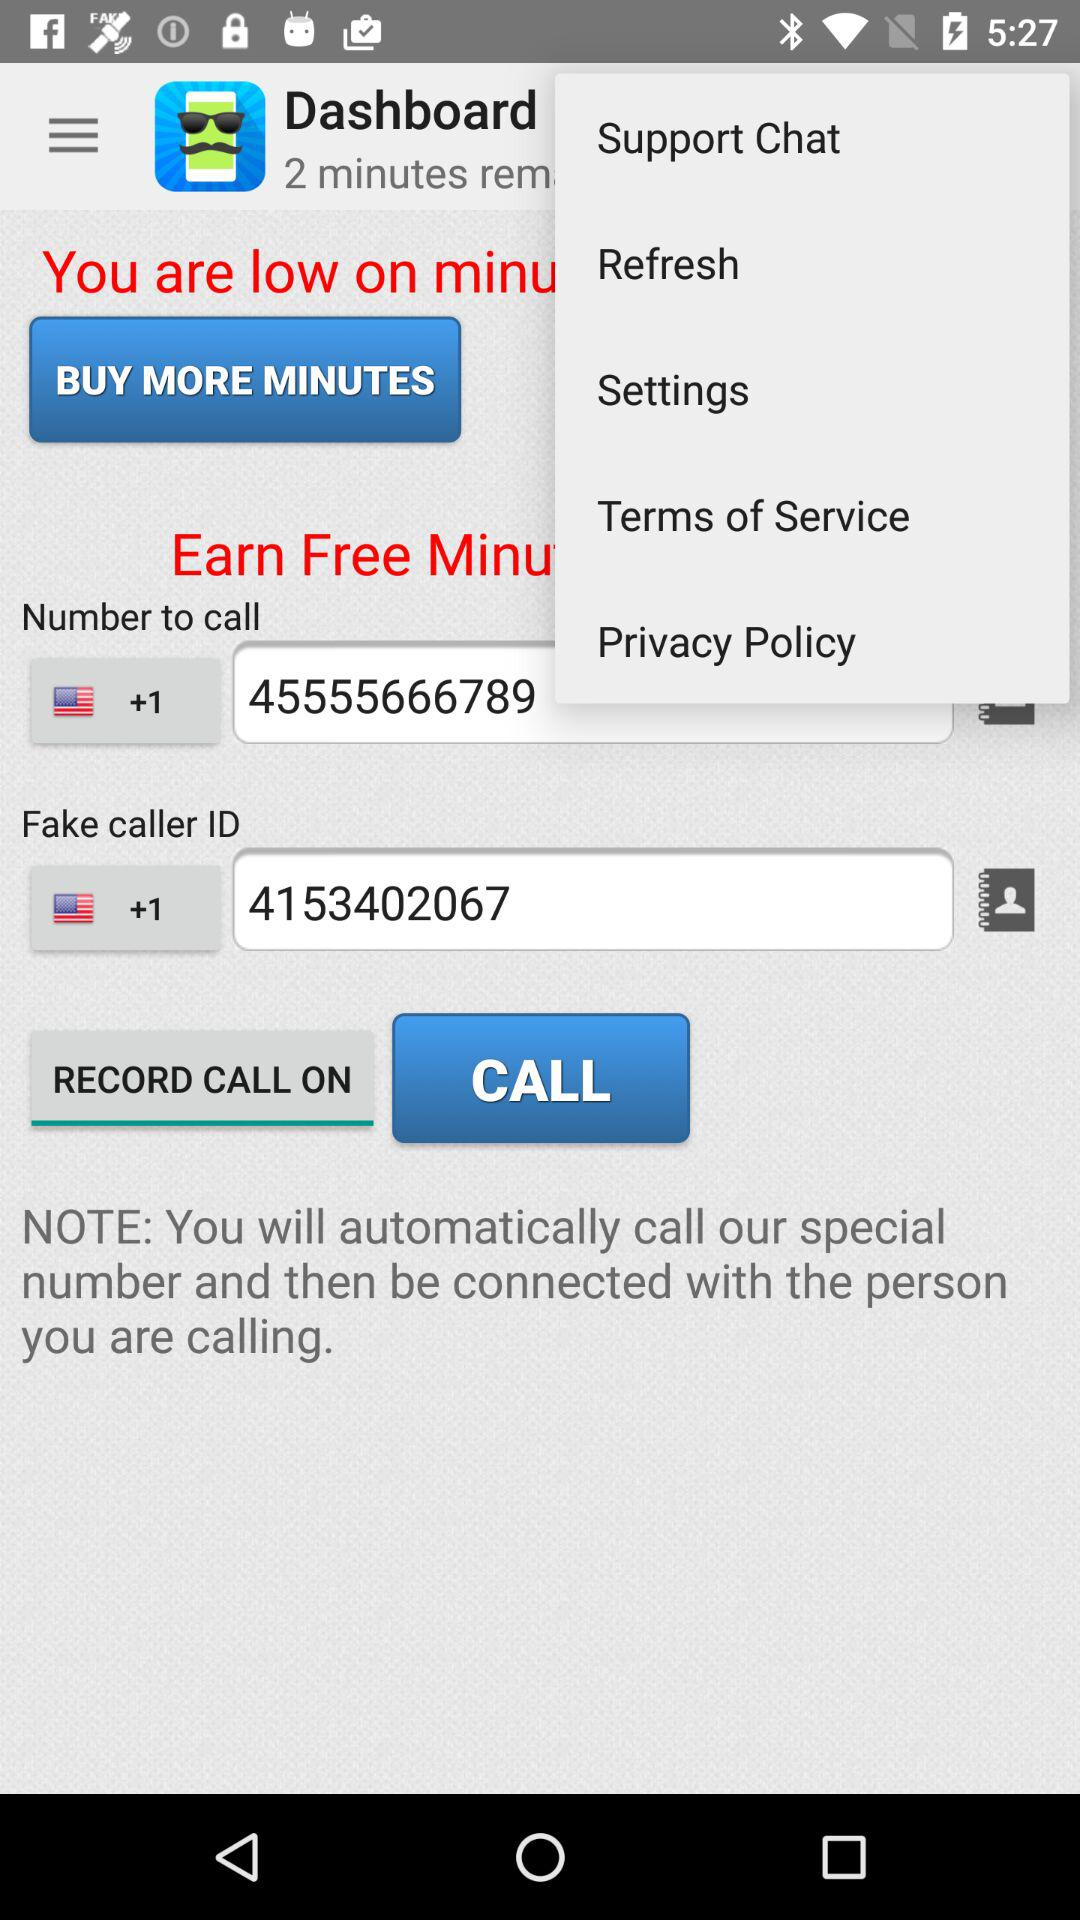What is the fake caller ID number? The fake caller ID number is +1 4153402067. 